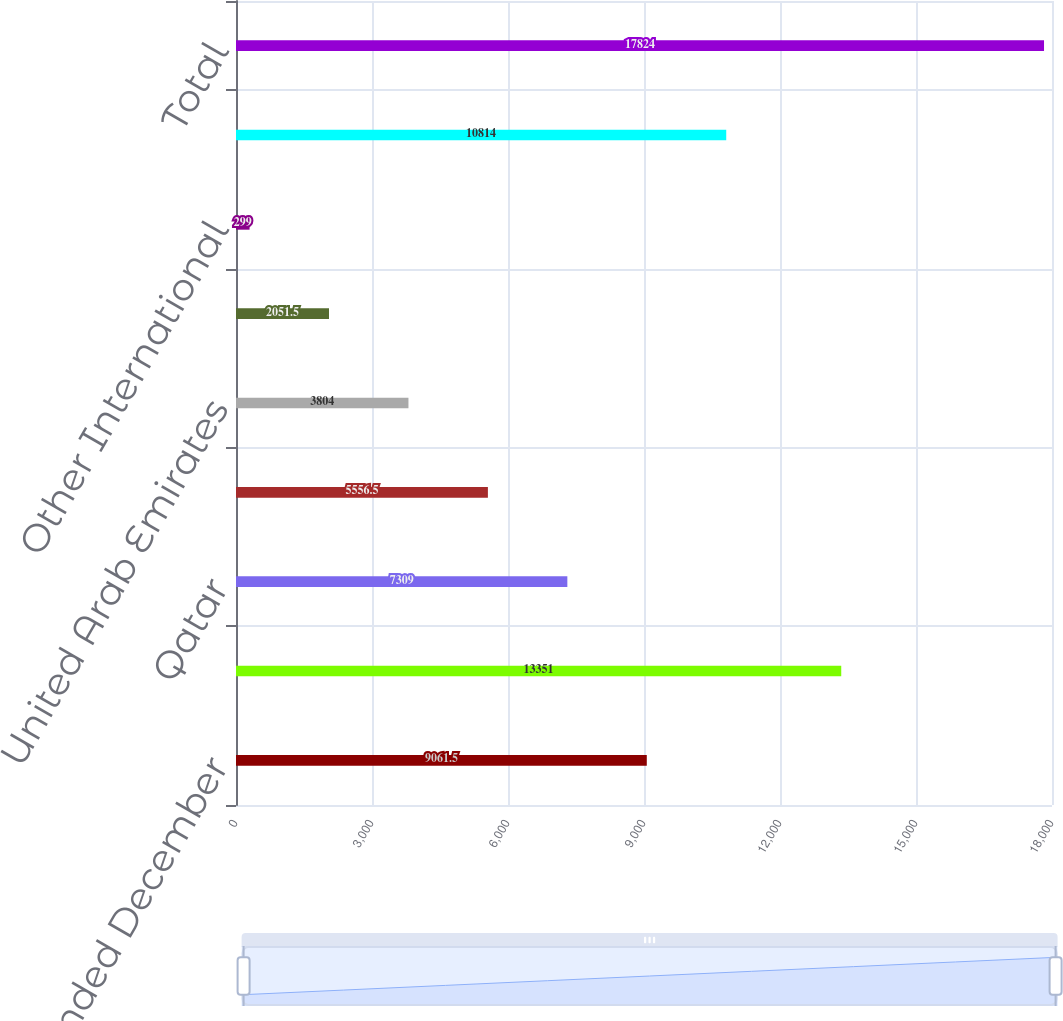<chart> <loc_0><loc_0><loc_500><loc_500><bar_chart><fcel>For the years ended December<fcel>United States<fcel>Qatar<fcel>Oman<fcel>United Arab Emirates<fcel>Colombia<fcel>Other International<fcel>Total International<fcel>Total<nl><fcel>9061.5<fcel>13351<fcel>7309<fcel>5556.5<fcel>3804<fcel>2051.5<fcel>299<fcel>10814<fcel>17824<nl></chart> 